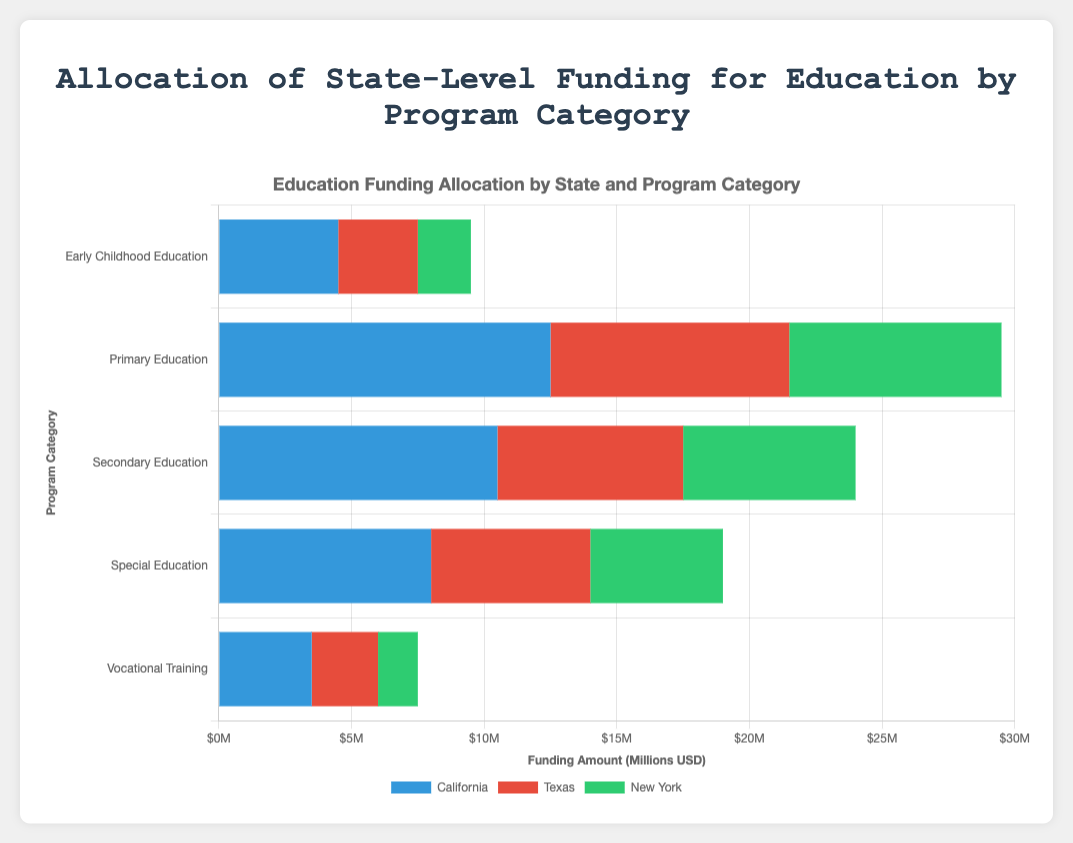Which state allocates the most funding for Primary Education? To determine which state allocates the most funding, reference the bar corresponding to Primary Education and identify the longest bar. In the chart, California allocates more funding compared to Texas and New York.
Answer: California How much more funding does California allocate for Secondary Education compared to Texas? Subtract the funding amount for Texas's Secondary Education from California's. California allocates $10.5M, and Texas allocates $7M. The difference is $10.5M - $7M = $3.5M.
Answer: $3.5M Which program category receives the least funding from New York? Identify the shortest bar among New York’s program categories. The bar for Vocational Training is the shortest, indicating it receives the least funding.
Answer: Vocational Training What's the total amount of funding allocated by Texas for all program categories? Add the funding amounts for all categories in Texas: $3M + $9M + $7M + $6M + $2.5M = $27.5M.
Answer: $27.5M Which program category is funded equally by two different states? Identify bars of equal length across different states. The funding for Secondary Education by New York ($6.5M) and Secondary Education by Texas ($6.5M) are equal.
Answer: Secondary Education How does the proportion of funding for Early Childhood Education compare between California and New York? Compare the bar lengths for Early Childhood Education in both states. California has a longer bar than New York, implying a higher funding proportion in California.
Answer: Higher in California What is the difference in funding allocation for Special Education between California and New York? Subtract New York's funding for Special Education from California's: $8M - $5M = $3M.
Answer: $3M Which state has the most balanced funding allocation (smallest difference between highest and lowest funding category)? Calculate the difference between the highest and lowest categories for each state:  
\- California: $12.5M - $3.5M ($9M)
\- Texas: $9M - $2.5M ($6.5M)
\- New York: $8M - $1.5M ($6.5M)  
Texas and New York both have the smallest difference ($6.5M).
Answer: Texas and New York How does the funding for Vocational Training in California compare visually with Texas? Observe and compare the lengths of the bars for Vocational Training in California and Texas. California’s bar is longer than Texas’s, indicating higher funding.
Answer: Higher in California 